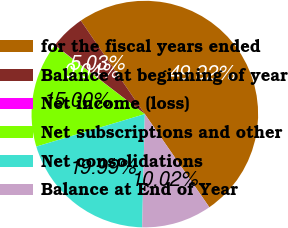Convert chart to OTSL. <chart><loc_0><loc_0><loc_500><loc_500><pie_chart><fcel>for the fiscal years ended<fcel>Balance at beginning of year<fcel>Net income (loss)<fcel>Net subscriptions and other<fcel>Net consolidations<fcel>Balance at End of Year<nl><fcel>49.92%<fcel>5.03%<fcel>0.04%<fcel>15.0%<fcel>19.99%<fcel>10.02%<nl></chart> 